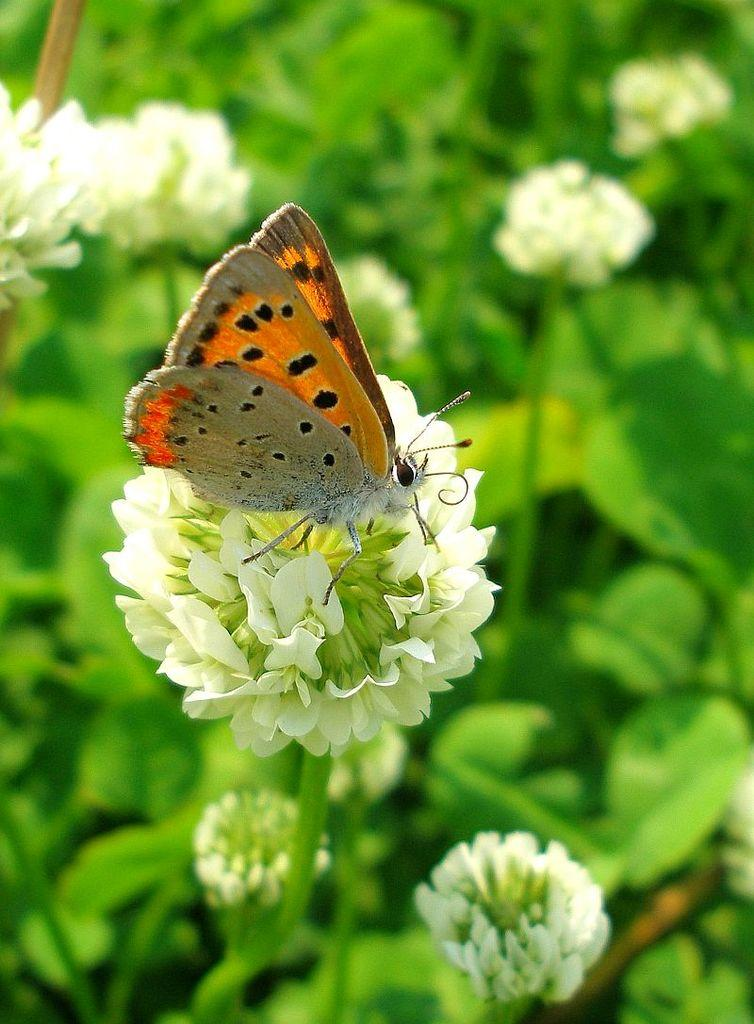What is on the white flower in the image? There is a butterfly on the white flower. What other flowers are present in the image? There are other flowers beside the white flower. What can be seen in the background of the image? The background consists of greenery. What type of bomb is being used to limit the growth of the flowers in the image? There is no bomb or any indication of limiting the growth of the flowers in the image. The image simply shows a butterfly on a white flower and other flowers in a background of greenery. 